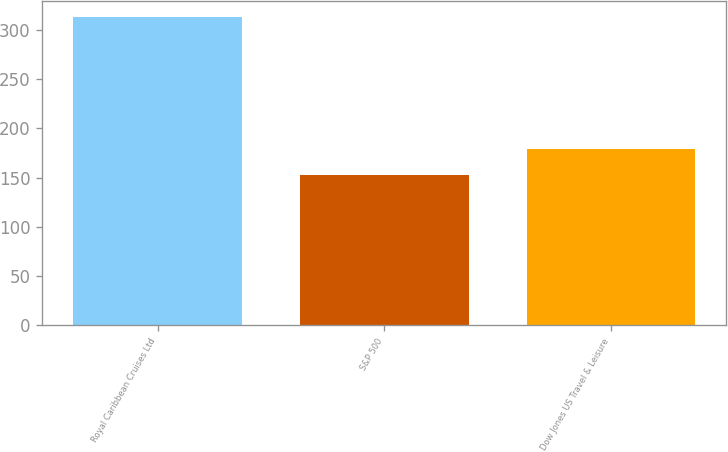<chart> <loc_0><loc_0><loc_500><loc_500><bar_chart><fcel>Royal Caribbean Cruises Ltd<fcel>S&P 500<fcel>Dow Jones US Travel & Leisure<nl><fcel>313.65<fcel>152.59<fcel>179.27<nl></chart> 